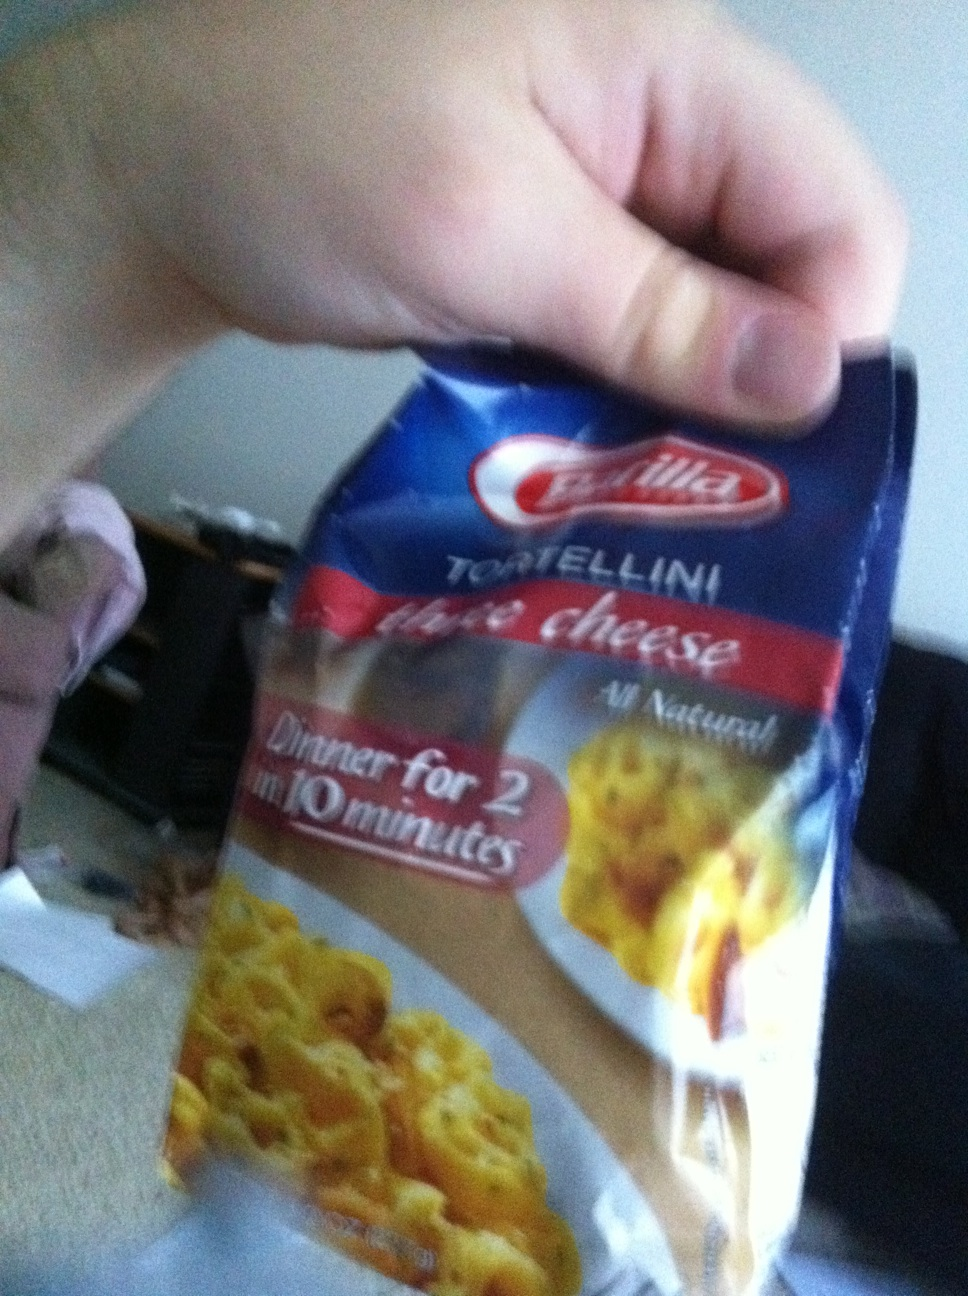What are the ingredients of this product? Barilla three cheese tortellini typically includes ingredients such as durum wheat semolina, ricotta cheese, Parmigiano Reggiano cheese, Grana Padano cheese, salt, and various natural flavorings. It's designed to offer a rich and creamy taste experience. 